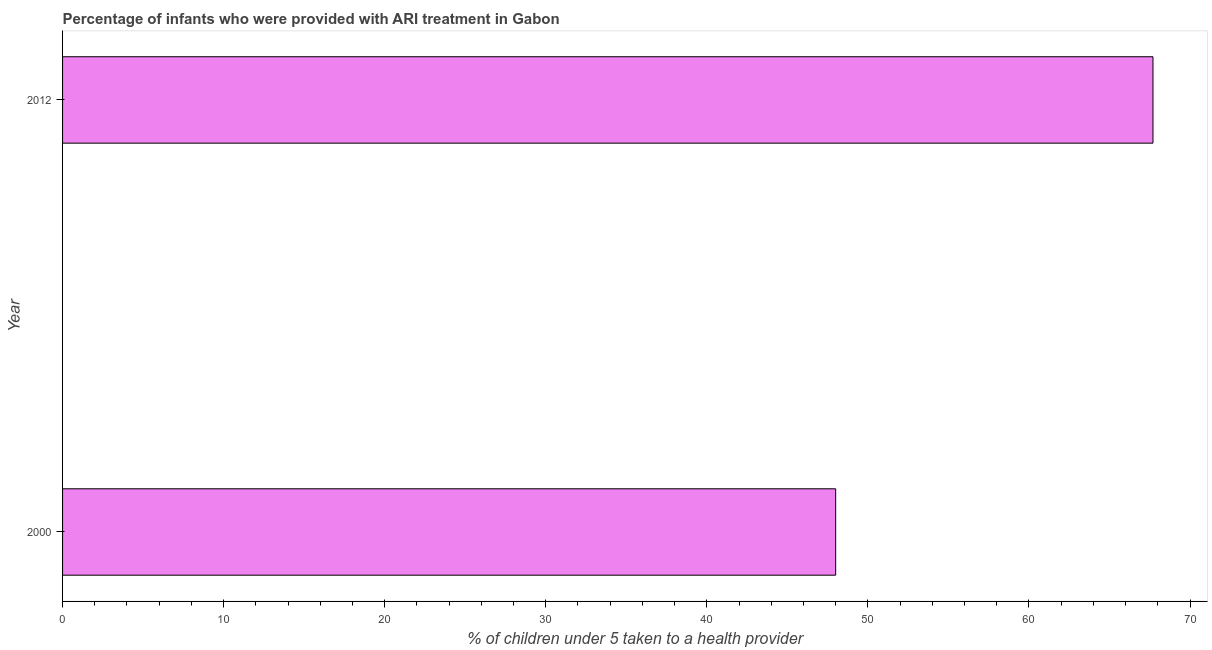What is the title of the graph?
Give a very brief answer. Percentage of infants who were provided with ARI treatment in Gabon. What is the label or title of the X-axis?
Ensure brevity in your answer.  % of children under 5 taken to a health provider. What is the label or title of the Y-axis?
Make the answer very short. Year. What is the percentage of children who were provided with ari treatment in 2012?
Your response must be concise. 67.7. Across all years, what is the maximum percentage of children who were provided with ari treatment?
Provide a succinct answer. 67.7. In which year was the percentage of children who were provided with ari treatment minimum?
Provide a succinct answer. 2000. What is the sum of the percentage of children who were provided with ari treatment?
Your response must be concise. 115.7. What is the difference between the percentage of children who were provided with ari treatment in 2000 and 2012?
Your answer should be compact. -19.7. What is the average percentage of children who were provided with ari treatment per year?
Ensure brevity in your answer.  57.85. What is the median percentage of children who were provided with ari treatment?
Ensure brevity in your answer.  57.85. In how many years, is the percentage of children who were provided with ari treatment greater than 62 %?
Provide a succinct answer. 1. Do a majority of the years between 2000 and 2012 (inclusive) have percentage of children who were provided with ari treatment greater than 68 %?
Provide a short and direct response. No. What is the ratio of the percentage of children who were provided with ari treatment in 2000 to that in 2012?
Your answer should be compact. 0.71. Is the percentage of children who were provided with ari treatment in 2000 less than that in 2012?
Provide a short and direct response. Yes. Are all the bars in the graph horizontal?
Make the answer very short. Yes. What is the % of children under 5 taken to a health provider of 2000?
Your answer should be compact. 48. What is the % of children under 5 taken to a health provider of 2012?
Give a very brief answer. 67.7. What is the difference between the % of children under 5 taken to a health provider in 2000 and 2012?
Ensure brevity in your answer.  -19.7. What is the ratio of the % of children under 5 taken to a health provider in 2000 to that in 2012?
Provide a short and direct response. 0.71. 